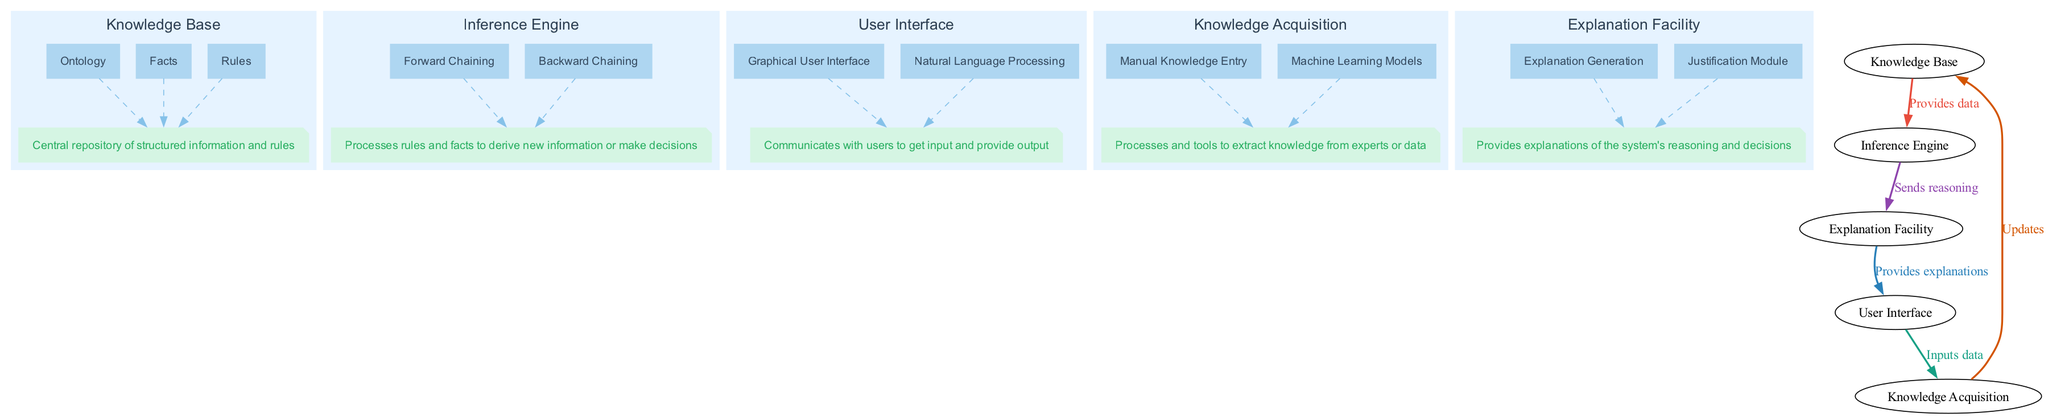What is the central repository in the diagram? The diagram clearly labels the "Knowledge Base" as the central repository of structured information and rules.
Answer: Knowledge Base How many components are in the Knowledge Base? The Knowledge Base has three components: Ontology, Facts, and Rules. This can be counted directly in the diagram representing the Knowledge Base.
Answer: 3 What type of approach does Backward Chaining represent? Backward Chaining is described in the diagram as a "Goal-driven approach for inference," which is explicitly stated in its component description.
Answer: Goal-driven Which component provides explanations of reasoning? The diagram specifies that the "Explanation Facility" is responsible for providing explanations of the system's reasoning and decisions, as noted in its description.
Answer: Explanation Facility Which components connect User Interface and Knowledge Acquisition? The arrows in the diagram show that the User Interface sends inputs to Knowledge Acquisition, thus indicating a direct connection between these two components.
Answer: Inputs data What color represents the connection from Knowledge Base to Inference Engine? The connection line between the Knowledge Base and Inference Engine is colored red, as marked in the diagram, indicating the significance of this relationship.
Answer: Red How many total main components are present in the diagram? By reviewing the diagram, one identifies five main components: Knowledge Base, Inference Engine, User Interface, Knowledge Acquisition, and Explanation Facility.
Answer: 5 What does the Explanation Generation component do? The diagram indicates that the Explanation Generation creates human-understandable explanations from the inference process, detailed within the explanation of the component.
Answer: Creates explanations How do the Inference Engine and Knowledge Base interact? The diagram shows that the Inference Engine receives data from the Knowledge Base to process rules and facts, highlighting their interaction in this AI system context.
Answer: Provides data What type of interface does the User Interface include? The User Interface is detailed to include a "Graphical User Interface" that facilitates visual interaction with the system, clearly stated in its components.
Answer: Graphical User Interface 